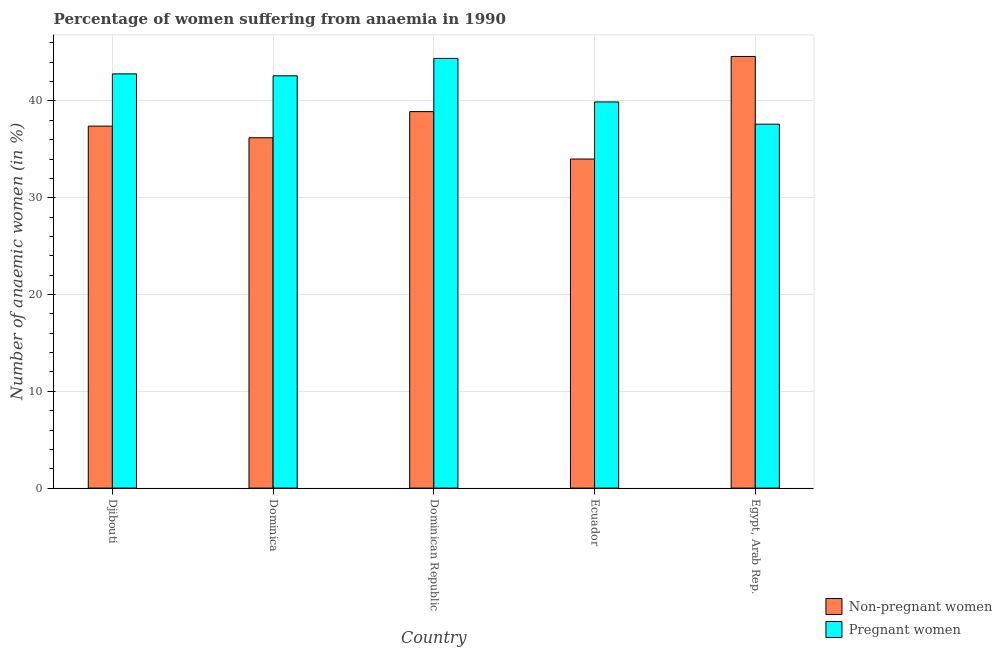Are the number of bars per tick equal to the number of legend labels?
Give a very brief answer. Yes. What is the label of the 3rd group of bars from the left?
Your response must be concise. Dominican Republic. Across all countries, what is the maximum percentage of pregnant anaemic women?
Ensure brevity in your answer.  44.4. Across all countries, what is the minimum percentage of pregnant anaemic women?
Give a very brief answer. 37.6. In which country was the percentage of pregnant anaemic women maximum?
Give a very brief answer. Dominican Republic. In which country was the percentage of non-pregnant anaemic women minimum?
Offer a terse response. Ecuador. What is the total percentage of non-pregnant anaemic women in the graph?
Give a very brief answer. 191.1. What is the difference between the percentage of pregnant anaemic women in Dominican Republic and that in Ecuador?
Offer a terse response. 4.5. What is the difference between the percentage of non-pregnant anaemic women in Djibouti and the percentage of pregnant anaemic women in Dominica?
Make the answer very short. -5.2. What is the average percentage of non-pregnant anaemic women per country?
Your answer should be very brief. 38.22. What is the difference between the percentage of non-pregnant anaemic women and percentage of pregnant anaemic women in Ecuador?
Your answer should be very brief. -5.9. What is the ratio of the percentage of non-pregnant anaemic women in Dominica to that in Egypt, Arab Rep.?
Provide a succinct answer. 0.81. Is the percentage of pregnant anaemic women in Dominican Republic less than that in Egypt, Arab Rep.?
Offer a terse response. No. Is the difference between the percentage of pregnant anaemic women in Ecuador and Egypt, Arab Rep. greater than the difference between the percentage of non-pregnant anaemic women in Ecuador and Egypt, Arab Rep.?
Offer a terse response. Yes. What is the difference between the highest and the second highest percentage of pregnant anaemic women?
Provide a short and direct response. 1.6. What is the difference between the highest and the lowest percentage of non-pregnant anaemic women?
Make the answer very short. 10.6. Is the sum of the percentage of pregnant anaemic women in Djibouti and Ecuador greater than the maximum percentage of non-pregnant anaemic women across all countries?
Provide a short and direct response. Yes. What does the 2nd bar from the left in Ecuador represents?
Ensure brevity in your answer.  Pregnant women. What does the 1st bar from the right in Ecuador represents?
Your response must be concise. Pregnant women. How many countries are there in the graph?
Your answer should be compact. 5. Does the graph contain any zero values?
Your answer should be very brief. No. Where does the legend appear in the graph?
Provide a succinct answer. Bottom right. How many legend labels are there?
Offer a very short reply. 2. What is the title of the graph?
Keep it short and to the point. Percentage of women suffering from anaemia in 1990. Does "Female labor force" appear as one of the legend labels in the graph?
Your answer should be compact. No. What is the label or title of the X-axis?
Keep it short and to the point. Country. What is the label or title of the Y-axis?
Give a very brief answer. Number of anaemic women (in %). What is the Number of anaemic women (in %) of Non-pregnant women in Djibouti?
Provide a succinct answer. 37.4. What is the Number of anaemic women (in %) of Pregnant women in Djibouti?
Your answer should be very brief. 42.8. What is the Number of anaemic women (in %) in Non-pregnant women in Dominica?
Your answer should be very brief. 36.2. What is the Number of anaemic women (in %) of Pregnant women in Dominica?
Offer a terse response. 42.6. What is the Number of anaemic women (in %) in Non-pregnant women in Dominican Republic?
Ensure brevity in your answer.  38.9. What is the Number of anaemic women (in %) in Pregnant women in Dominican Republic?
Keep it short and to the point. 44.4. What is the Number of anaemic women (in %) in Pregnant women in Ecuador?
Make the answer very short. 39.9. What is the Number of anaemic women (in %) of Non-pregnant women in Egypt, Arab Rep.?
Make the answer very short. 44.6. What is the Number of anaemic women (in %) in Pregnant women in Egypt, Arab Rep.?
Give a very brief answer. 37.6. Across all countries, what is the maximum Number of anaemic women (in %) in Non-pregnant women?
Provide a short and direct response. 44.6. Across all countries, what is the maximum Number of anaemic women (in %) of Pregnant women?
Your answer should be compact. 44.4. Across all countries, what is the minimum Number of anaemic women (in %) of Pregnant women?
Offer a terse response. 37.6. What is the total Number of anaemic women (in %) of Non-pregnant women in the graph?
Offer a very short reply. 191.1. What is the total Number of anaemic women (in %) in Pregnant women in the graph?
Your answer should be compact. 207.3. What is the difference between the Number of anaemic women (in %) of Non-pregnant women in Djibouti and that in Dominican Republic?
Provide a short and direct response. -1.5. What is the difference between the Number of anaemic women (in %) of Non-pregnant women in Djibouti and that in Egypt, Arab Rep.?
Your answer should be compact. -7.2. What is the difference between the Number of anaemic women (in %) of Pregnant women in Djibouti and that in Egypt, Arab Rep.?
Offer a terse response. 5.2. What is the difference between the Number of anaemic women (in %) of Non-pregnant women in Dominica and that in Dominican Republic?
Provide a succinct answer. -2.7. What is the difference between the Number of anaemic women (in %) in Pregnant women in Dominica and that in Dominican Republic?
Offer a very short reply. -1.8. What is the difference between the Number of anaemic women (in %) of Pregnant women in Dominica and that in Ecuador?
Keep it short and to the point. 2.7. What is the difference between the Number of anaemic women (in %) of Pregnant women in Dominica and that in Egypt, Arab Rep.?
Your answer should be very brief. 5. What is the difference between the Number of anaemic women (in %) of Pregnant women in Dominican Republic and that in Ecuador?
Offer a terse response. 4.5. What is the difference between the Number of anaemic women (in %) in Pregnant women in Ecuador and that in Egypt, Arab Rep.?
Ensure brevity in your answer.  2.3. What is the difference between the Number of anaemic women (in %) in Non-pregnant women in Djibouti and the Number of anaemic women (in %) in Pregnant women in Dominica?
Provide a short and direct response. -5.2. What is the difference between the Number of anaemic women (in %) in Non-pregnant women in Djibouti and the Number of anaemic women (in %) in Pregnant women in Dominican Republic?
Keep it short and to the point. -7. What is the difference between the Number of anaemic women (in %) of Non-pregnant women in Dominica and the Number of anaemic women (in %) of Pregnant women in Ecuador?
Provide a succinct answer. -3.7. What is the difference between the Number of anaemic women (in %) of Non-pregnant women in Dominica and the Number of anaemic women (in %) of Pregnant women in Egypt, Arab Rep.?
Offer a very short reply. -1.4. What is the difference between the Number of anaemic women (in %) of Non-pregnant women in Ecuador and the Number of anaemic women (in %) of Pregnant women in Egypt, Arab Rep.?
Offer a very short reply. -3.6. What is the average Number of anaemic women (in %) of Non-pregnant women per country?
Offer a very short reply. 38.22. What is the average Number of anaemic women (in %) of Pregnant women per country?
Give a very brief answer. 41.46. What is the difference between the Number of anaemic women (in %) in Non-pregnant women and Number of anaemic women (in %) in Pregnant women in Dominica?
Ensure brevity in your answer.  -6.4. What is the difference between the Number of anaemic women (in %) of Non-pregnant women and Number of anaemic women (in %) of Pregnant women in Ecuador?
Provide a short and direct response. -5.9. What is the ratio of the Number of anaemic women (in %) of Non-pregnant women in Djibouti to that in Dominica?
Offer a very short reply. 1.03. What is the ratio of the Number of anaemic women (in %) of Non-pregnant women in Djibouti to that in Dominican Republic?
Your answer should be very brief. 0.96. What is the ratio of the Number of anaemic women (in %) in Pregnant women in Djibouti to that in Ecuador?
Make the answer very short. 1.07. What is the ratio of the Number of anaemic women (in %) of Non-pregnant women in Djibouti to that in Egypt, Arab Rep.?
Offer a very short reply. 0.84. What is the ratio of the Number of anaemic women (in %) in Pregnant women in Djibouti to that in Egypt, Arab Rep.?
Keep it short and to the point. 1.14. What is the ratio of the Number of anaemic women (in %) in Non-pregnant women in Dominica to that in Dominican Republic?
Your answer should be compact. 0.93. What is the ratio of the Number of anaemic women (in %) in Pregnant women in Dominica to that in Dominican Republic?
Provide a succinct answer. 0.96. What is the ratio of the Number of anaemic women (in %) in Non-pregnant women in Dominica to that in Ecuador?
Offer a very short reply. 1.06. What is the ratio of the Number of anaemic women (in %) in Pregnant women in Dominica to that in Ecuador?
Ensure brevity in your answer.  1.07. What is the ratio of the Number of anaemic women (in %) in Non-pregnant women in Dominica to that in Egypt, Arab Rep.?
Offer a very short reply. 0.81. What is the ratio of the Number of anaemic women (in %) in Pregnant women in Dominica to that in Egypt, Arab Rep.?
Offer a terse response. 1.13. What is the ratio of the Number of anaemic women (in %) in Non-pregnant women in Dominican Republic to that in Ecuador?
Your answer should be very brief. 1.14. What is the ratio of the Number of anaemic women (in %) in Pregnant women in Dominican Republic to that in Ecuador?
Provide a short and direct response. 1.11. What is the ratio of the Number of anaemic women (in %) in Non-pregnant women in Dominican Republic to that in Egypt, Arab Rep.?
Ensure brevity in your answer.  0.87. What is the ratio of the Number of anaemic women (in %) in Pregnant women in Dominican Republic to that in Egypt, Arab Rep.?
Your answer should be compact. 1.18. What is the ratio of the Number of anaemic women (in %) in Non-pregnant women in Ecuador to that in Egypt, Arab Rep.?
Keep it short and to the point. 0.76. What is the ratio of the Number of anaemic women (in %) of Pregnant women in Ecuador to that in Egypt, Arab Rep.?
Your response must be concise. 1.06. What is the difference between the highest and the second highest Number of anaemic women (in %) in Non-pregnant women?
Provide a short and direct response. 5.7. 